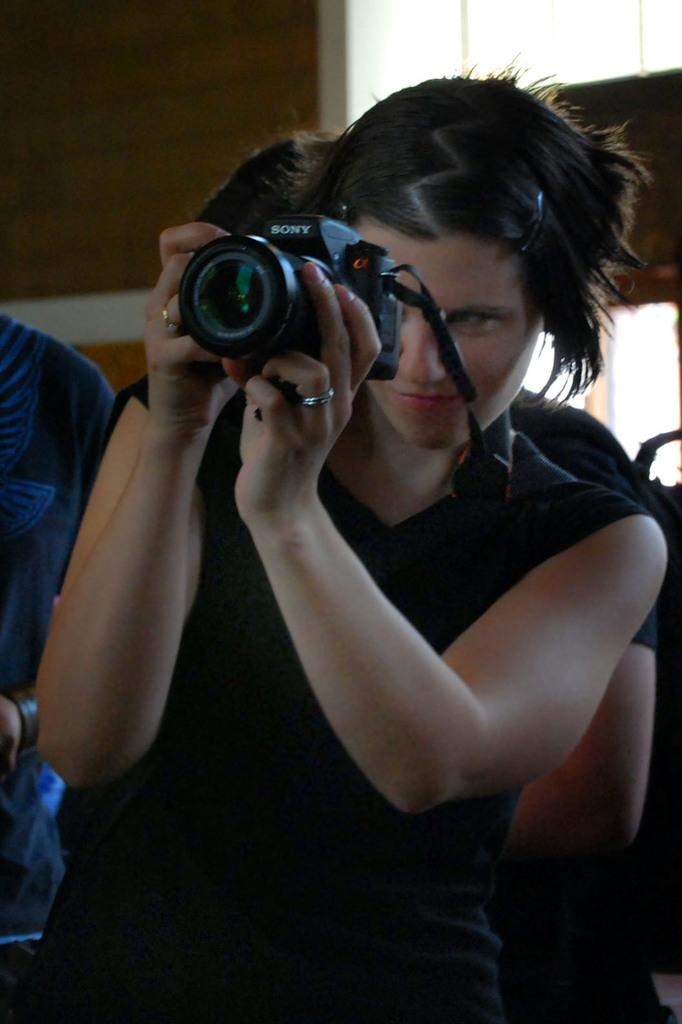Who is the main subject in the image? There is a woman in the image. What is the woman holding in the image? The woman is holding a camera. What color is the top that the woman is wearing? The woman is wearing a black top. Can you describe the background of the image? There are people visible in the background of the image. What type of soap is the woman using to clean the pot in the image? There is no soap or pot present in the image. How does the woman express regret in the image? There is no indication of regret in the image; the woman is holding a camera and appears to be taking a photo. 